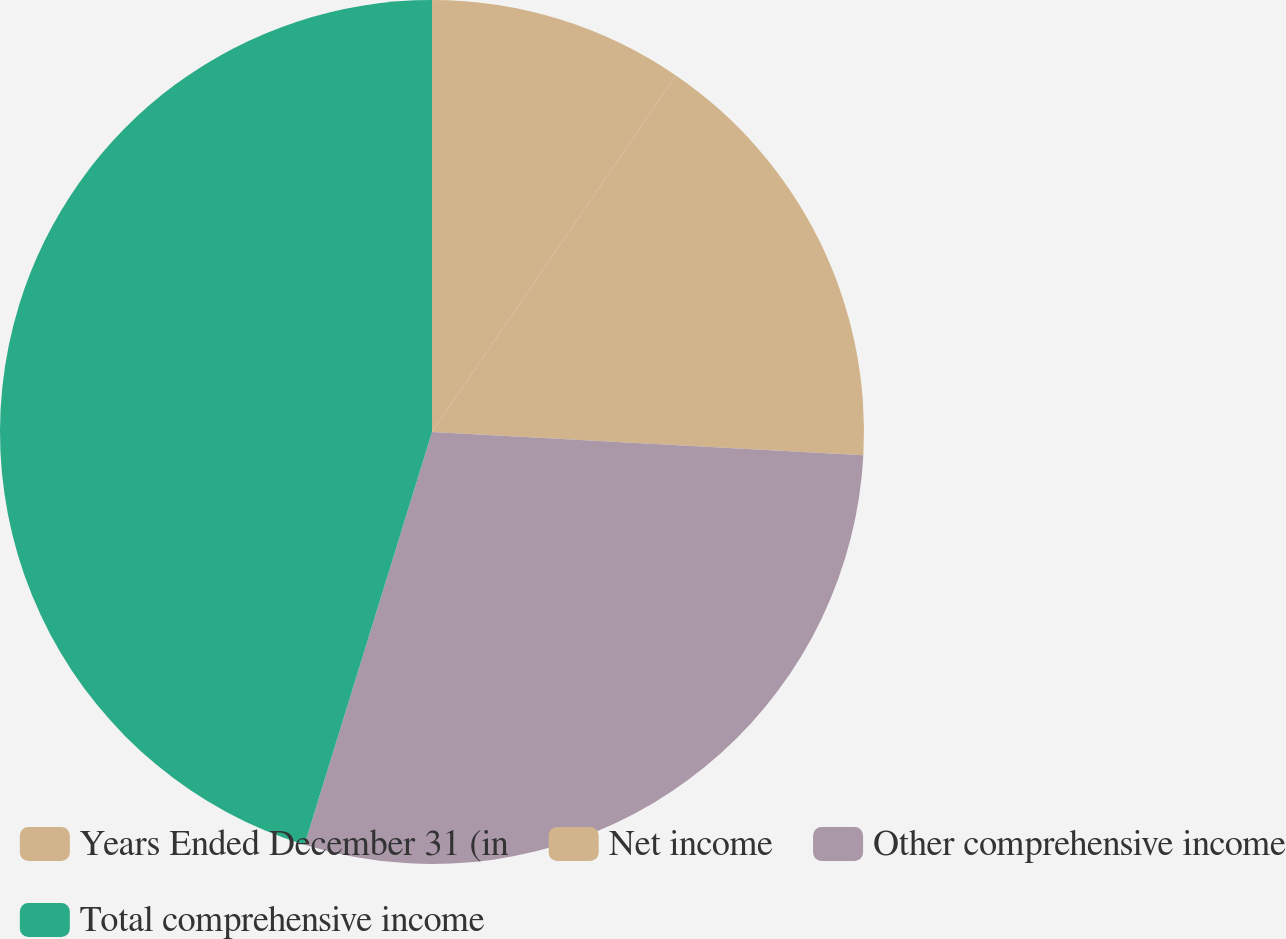Convert chart. <chart><loc_0><loc_0><loc_500><loc_500><pie_chart><fcel>Years Ended December 31 (in<fcel>Net income<fcel>Other comprehensive income<fcel>Total comprehensive income<nl><fcel>9.55%<fcel>16.31%<fcel>28.91%<fcel>45.23%<nl></chart> 